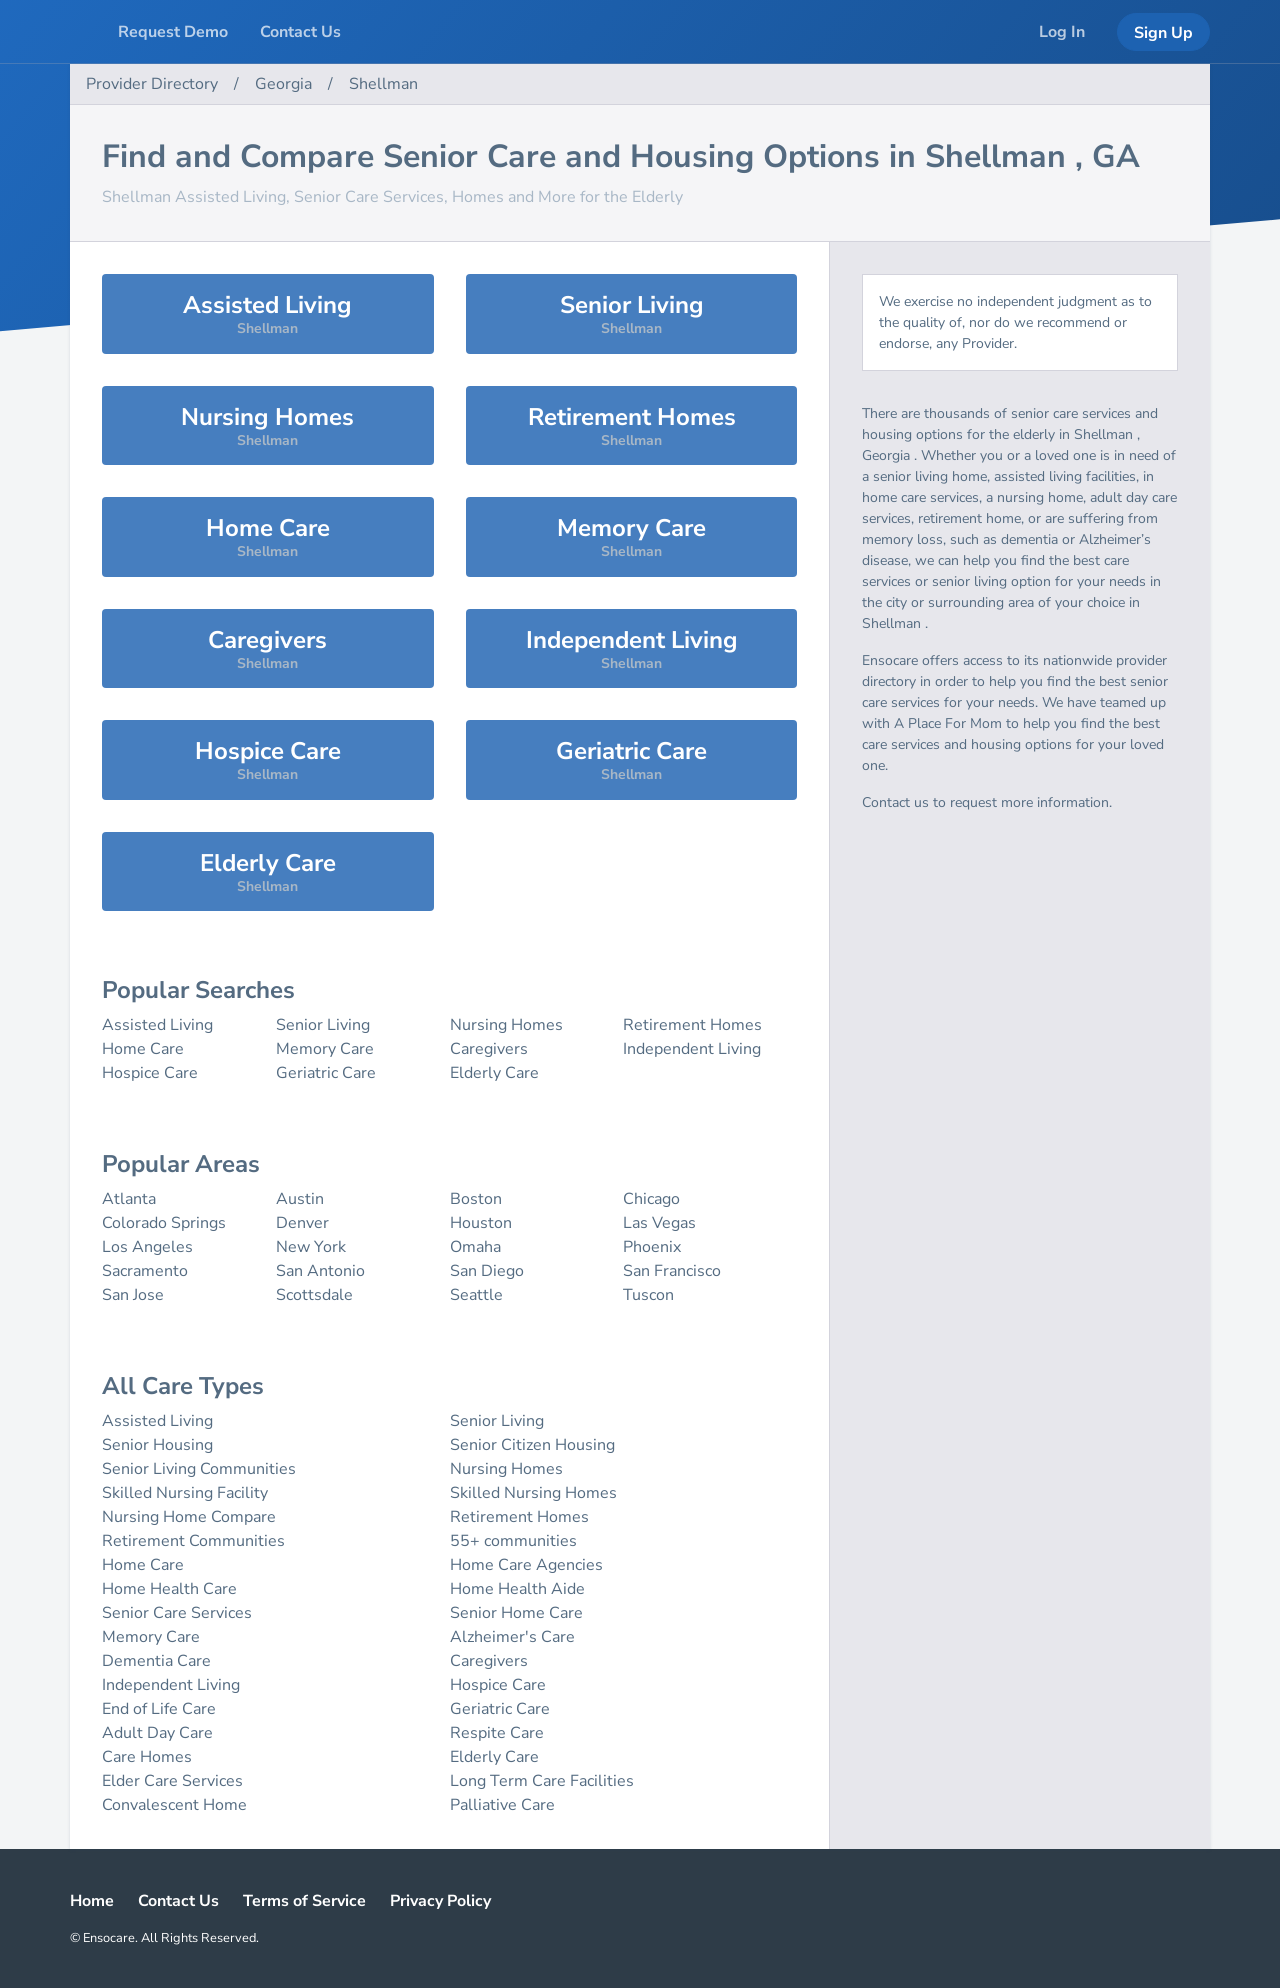What's the procedure for constructing this website from scratch with HTML? The procedure for constructing a website like the one shown in the image, which focuses on listing senior care and housing options in Shellman, GA, involves several steps. Firstly, you would create the basic HTML structure with sections for navigation, main content, and footer. You would then style the website using CSS to achieve a clean and accessible layout. Important aspects would include setting up responsive categories such as 'Assisted Living', 'Senior Living', etc., and ensuring the site is user-friendly, especially for seniors. Lastly, you might consider adding JavaScript for interactive elements, like search functionality or sorting options. 